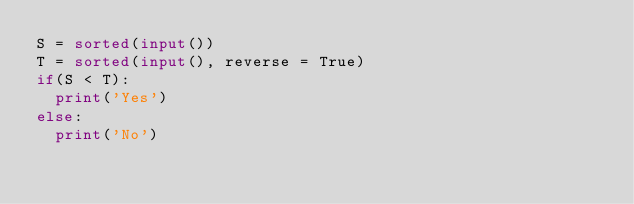Convert code to text. <code><loc_0><loc_0><loc_500><loc_500><_Python_>S = sorted(input())
T = sorted(input(), reverse = True)
if(S < T):
  print('Yes')
else:
  print('No')</code> 